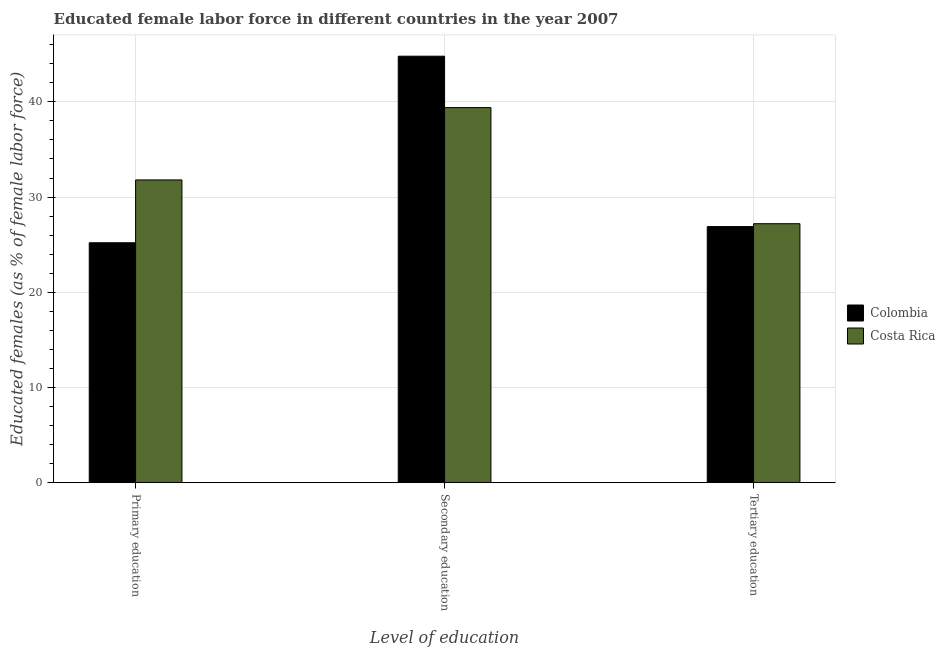How many groups of bars are there?
Offer a terse response. 3. How many bars are there on the 2nd tick from the left?
Give a very brief answer. 2. What is the label of the 2nd group of bars from the left?
Your answer should be compact. Secondary education. What is the percentage of female labor force who received tertiary education in Costa Rica?
Provide a succinct answer. 27.2. Across all countries, what is the maximum percentage of female labor force who received primary education?
Make the answer very short. 31.8. Across all countries, what is the minimum percentage of female labor force who received secondary education?
Offer a terse response. 39.4. In which country was the percentage of female labor force who received secondary education maximum?
Offer a terse response. Colombia. In which country was the percentage of female labor force who received secondary education minimum?
Ensure brevity in your answer.  Costa Rica. What is the total percentage of female labor force who received tertiary education in the graph?
Your answer should be very brief. 54.1. What is the difference between the percentage of female labor force who received tertiary education in Colombia and that in Costa Rica?
Provide a short and direct response. -0.3. What is the difference between the percentage of female labor force who received primary education and percentage of female labor force who received secondary education in Costa Rica?
Ensure brevity in your answer.  -7.6. In how many countries, is the percentage of female labor force who received primary education greater than 44 %?
Offer a terse response. 0. What is the ratio of the percentage of female labor force who received primary education in Costa Rica to that in Colombia?
Keep it short and to the point. 1.26. What is the difference between the highest and the second highest percentage of female labor force who received tertiary education?
Give a very brief answer. 0.3. What is the difference between the highest and the lowest percentage of female labor force who received tertiary education?
Ensure brevity in your answer.  0.3. What does the 1st bar from the left in Tertiary education represents?
Give a very brief answer. Colombia. How many bars are there?
Ensure brevity in your answer.  6. Are all the bars in the graph horizontal?
Make the answer very short. No. How many countries are there in the graph?
Offer a very short reply. 2. Are the values on the major ticks of Y-axis written in scientific E-notation?
Offer a terse response. No. Does the graph contain any zero values?
Provide a short and direct response. No. Where does the legend appear in the graph?
Keep it short and to the point. Center right. How are the legend labels stacked?
Ensure brevity in your answer.  Vertical. What is the title of the graph?
Give a very brief answer. Educated female labor force in different countries in the year 2007. What is the label or title of the X-axis?
Ensure brevity in your answer.  Level of education. What is the label or title of the Y-axis?
Make the answer very short. Educated females (as % of female labor force). What is the Educated females (as % of female labor force) in Colombia in Primary education?
Make the answer very short. 25.2. What is the Educated females (as % of female labor force) of Costa Rica in Primary education?
Your response must be concise. 31.8. What is the Educated females (as % of female labor force) in Colombia in Secondary education?
Keep it short and to the point. 44.8. What is the Educated females (as % of female labor force) of Costa Rica in Secondary education?
Your response must be concise. 39.4. What is the Educated females (as % of female labor force) in Colombia in Tertiary education?
Your response must be concise. 26.9. What is the Educated females (as % of female labor force) of Costa Rica in Tertiary education?
Ensure brevity in your answer.  27.2. Across all Level of education, what is the maximum Educated females (as % of female labor force) of Colombia?
Give a very brief answer. 44.8. Across all Level of education, what is the maximum Educated females (as % of female labor force) in Costa Rica?
Offer a very short reply. 39.4. Across all Level of education, what is the minimum Educated females (as % of female labor force) in Colombia?
Make the answer very short. 25.2. Across all Level of education, what is the minimum Educated females (as % of female labor force) in Costa Rica?
Keep it short and to the point. 27.2. What is the total Educated females (as % of female labor force) in Colombia in the graph?
Ensure brevity in your answer.  96.9. What is the total Educated females (as % of female labor force) in Costa Rica in the graph?
Offer a terse response. 98.4. What is the difference between the Educated females (as % of female labor force) in Colombia in Primary education and that in Secondary education?
Your answer should be compact. -19.6. What is the difference between the Educated females (as % of female labor force) of Costa Rica in Primary education and that in Secondary education?
Give a very brief answer. -7.6. What is the difference between the Educated females (as % of female labor force) in Colombia in Primary education and that in Tertiary education?
Your answer should be compact. -1.7. What is the difference between the Educated females (as % of female labor force) of Costa Rica in Primary education and that in Tertiary education?
Ensure brevity in your answer.  4.6. What is the difference between the Educated females (as % of female labor force) of Colombia in Secondary education and that in Tertiary education?
Your answer should be compact. 17.9. What is the difference between the Educated females (as % of female labor force) in Colombia in Primary education and the Educated females (as % of female labor force) in Costa Rica in Secondary education?
Offer a terse response. -14.2. What is the difference between the Educated females (as % of female labor force) in Colombia in Secondary education and the Educated females (as % of female labor force) in Costa Rica in Tertiary education?
Your answer should be very brief. 17.6. What is the average Educated females (as % of female labor force) in Colombia per Level of education?
Ensure brevity in your answer.  32.3. What is the average Educated females (as % of female labor force) in Costa Rica per Level of education?
Your response must be concise. 32.8. What is the difference between the Educated females (as % of female labor force) in Colombia and Educated females (as % of female labor force) in Costa Rica in Secondary education?
Give a very brief answer. 5.4. What is the ratio of the Educated females (as % of female labor force) in Colombia in Primary education to that in Secondary education?
Provide a succinct answer. 0.56. What is the ratio of the Educated females (as % of female labor force) of Costa Rica in Primary education to that in Secondary education?
Keep it short and to the point. 0.81. What is the ratio of the Educated females (as % of female labor force) in Colombia in Primary education to that in Tertiary education?
Provide a succinct answer. 0.94. What is the ratio of the Educated females (as % of female labor force) of Costa Rica in Primary education to that in Tertiary education?
Give a very brief answer. 1.17. What is the ratio of the Educated females (as % of female labor force) in Colombia in Secondary education to that in Tertiary education?
Ensure brevity in your answer.  1.67. What is the ratio of the Educated females (as % of female labor force) in Costa Rica in Secondary education to that in Tertiary education?
Ensure brevity in your answer.  1.45. What is the difference between the highest and the second highest Educated females (as % of female labor force) in Colombia?
Your answer should be very brief. 17.9. What is the difference between the highest and the second highest Educated females (as % of female labor force) in Costa Rica?
Give a very brief answer. 7.6. What is the difference between the highest and the lowest Educated females (as % of female labor force) in Colombia?
Give a very brief answer. 19.6. 